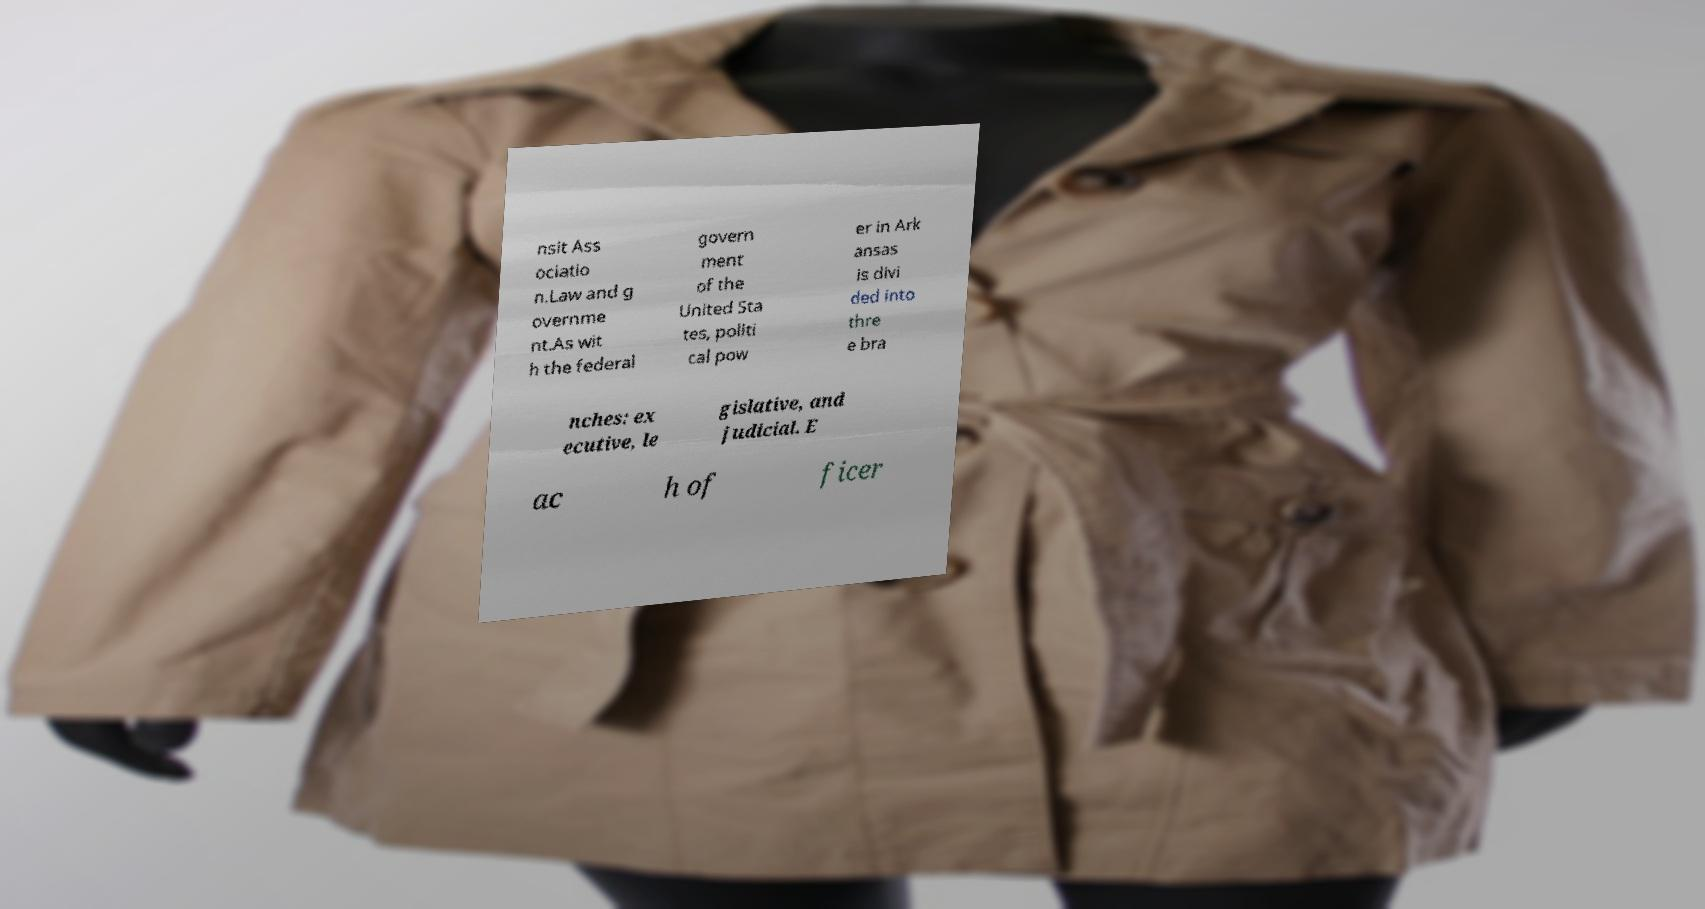Can you accurately transcribe the text from the provided image for me? nsit Ass ociatio n.Law and g overnme nt.As wit h the federal govern ment of the United Sta tes, politi cal pow er in Ark ansas is divi ded into thre e bra nches: ex ecutive, le gislative, and judicial. E ac h of ficer 